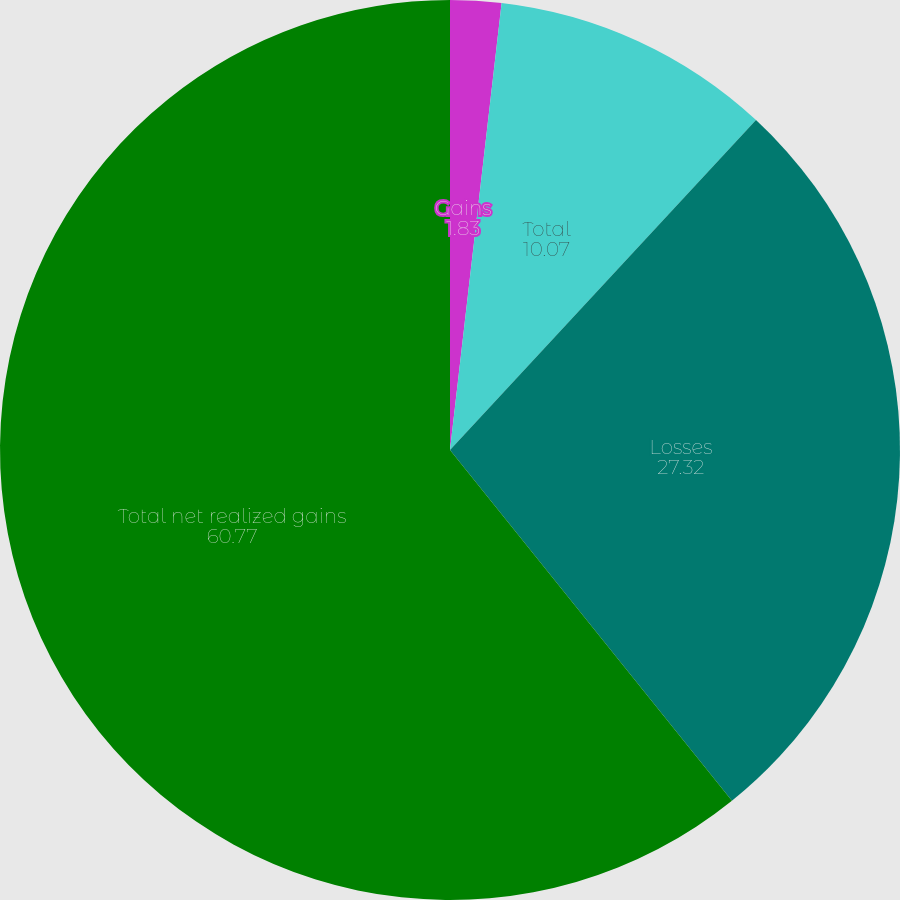<chart> <loc_0><loc_0><loc_500><loc_500><pie_chart><fcel>Gains<fcel>Total<fcel>Losses<fcel>Total net realized gains<nl><fcel>1.83%<fcel>10.07%<fcel>27.32%<fcel>60.77%<nl></chart> 